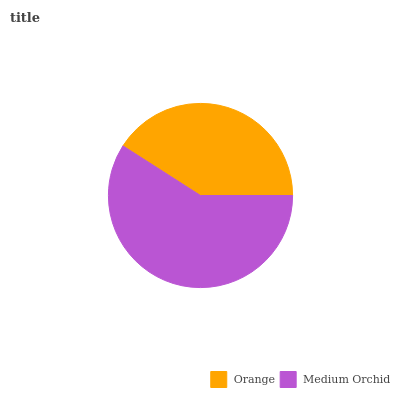Is Orange the minimum?
Answer yes or no. Yes. Is Medium Orchid the maximum?
Answer yes or no. Yes. Is Medium Orchid the minimum?
Answer yes or no. No. Is Medium Orchid greater than Orange?
Answer yes or no. Yes. Is Orange less than Medium Orchid?
Answer yes or no. Yes. Is Orange greater than Medium Orchid?
Answer yes or no. No. Is Medium Orchid less than Orange?
Answer yes or no. No. Is Medium Orchid the high median?
Answer yes or no. Yes. Is Orange the low median?
Answer yes or no. Yes. Is Orange the high median?
Answer yes or no. No. Is Medium Orchid the low median?
Answer yes or no. No. 